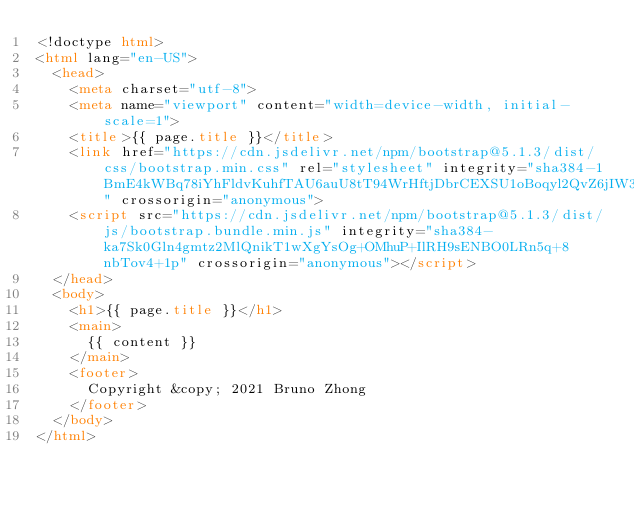Convert code to text. <code><loc_0><loc_0><loc_500><loc_500><_HTML_><!doctype html>
<html lang="en-US">
  <head>
    <meta charset="utf-8">
    <meta name="viewport" content="width=device-width, initial-scale=1">
    <title>{{ page.title }}</title>
    <link href="https://cdn.jsdelivr.net/npm/bootstrap@5.1.3/dist/css/bootstrap.min.css" rel="stylesheet" integrity="sha384-1BmE4kWBq78iYhFldvKuhfTAU6auU8tT94WrHftjDbrCEXSU1oBoqyl2QvZ6jIW3" crossorigin="anonymous">
    <script src="https://cdn.jsdelivr.net/npm/bootstrap@5.1.3/dist/js/bootstrap.bundle.min.js" integrity="sha384-ka7Sk0Gln4gmtz2MlQnikT1wXgYsOg+OMhuP+IlRH9sENBO0LRn5q+8nbTov4+1p" crossorigin="anonymous"></script>
  </head>
  <body>
    <h1>{{ page.title }}</h1>
    <main>
      {{ content }}
    </main>
    <footer>
      Copyright &copy; 2021 Bruno Zhong
    </footer>
  </body>
</html>
</code> 